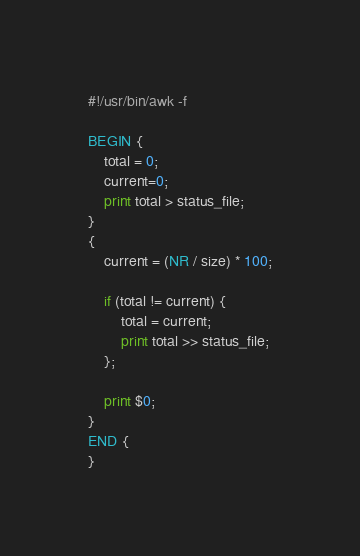<code> <loc_0><loc_0><loc_500><loc_500><_Awk_>#!/usr/bin/awk -f

BEGIN {
    total = 0;
    current=0;
    print total > status_file;
}
{
    current = (NR / size) * 100;

    if (total != current) {
        total = current;
        print total >> status_file;
    };

    print $0;
}
END {
}
</code> 